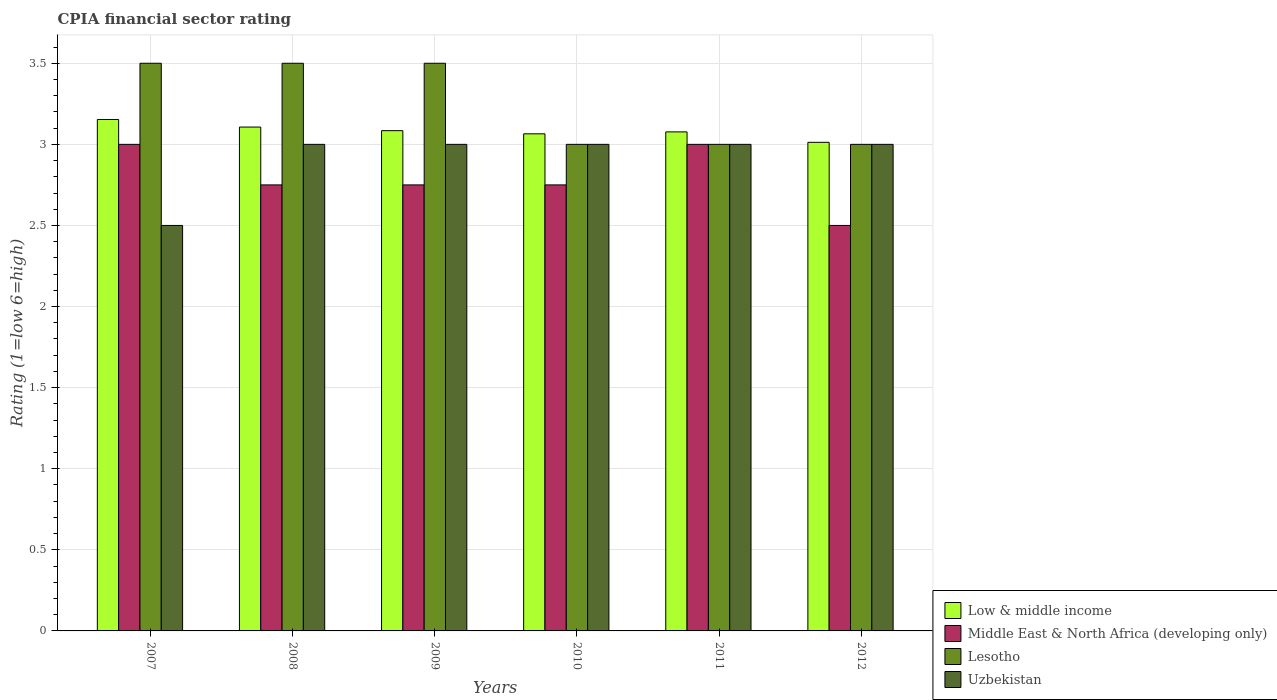How many different coloured bars are there?
Offer a very short reply. 4. How many groups of bars are there?
Your response must be concise. 6. How many bars are there on the 5th tick from the left?
Offer a terse response. 4. What is the label of the 5th group of bars from the left?
Your answer should be very brief. 2011. In how many cases, is the number of bars for a given year not equal to the number of legend labels?
Your answer should be very brief. 0. What is the total CPIA rating in Middle East & North Africa (developing only) in the graph?
Offer a very short reply. 16.75. What is the difference between the CPIA rating in Low & middle income in 2010 and that in 2011?
Offer a terse response. -0.01. What is the difference between the CPIA rating in Uzbekistan in 2007 and the CPIA rating in Low & middle income in 2010?
Provide a succinct answer. -0.56. What is the average CPIA rating in Low & middle income per year?
Offer a terse response. 3.08. In the year 2011, what is the difference between the CPIA rating in Lesotho and CPIA rating in Low & middle income?
Make the answer very short. -0.08. In how many years, is the CPIA rating in Low & middle income greater than 2.6?
Provide a succinct answer. 6. What is the ratio of the CPIA rating in Middle East & North Africa (developing only) in 2007 to that in 2010?
Offer a terse response. 1.09. Is the CPIA rating in Lesotho in 2008 less than that in 2009?
Ensure brevity in your answer.  No. What is the difference between the highest and the second highest CPIA rating in Lesotho?
Provide a succinct answer. 0. In how many years, is the CPIA rating in Middle East & North Africa (developing only) greater than the average CPIA rating in Middle East & North Africa (developing only) taken over all years?
Give a very brief answer. 2. What does the 2nd bar from the left in 2010 represents?
Offer a very short reply. Middle East & North Africa (developing only). What does the 1st bar from the right in 2011 represents?
Provide a short and direct response. Uzbekistan. Does the graph contain any zero values?
Offer a very short reply. No. Does the graph contain grids?
Provide a short and direct response. Yes. Where does the legend appear in the graph?
Your answer should be compact. Bottom right. How many legend labels are there?
Give a very brief answer. 4. What is the title of the graph?
Your response must be concise. CPIA financial sector rating. What is the label or title of the X-axis?
Your response must be concise. Years. What is the label or title of the Y-axis?
Give a very brief answer. Rating (1=low 6=high). What is the Rating (1=low 6=high) in Low & middle income in 2007?
Ensure brevity in your answer.  3.15. What is the Rating (1=low 6=high) of Lesotho in 2007?
Your answer should be very brief. 3.5. What is the Rating (1=low 6=high) of Low & middle income in 2008?
Your response must be concise. 3.11. What is the Rating (1=low 6=high) in Middle East & North Africa (developing only) in 2008?
Offer a terse response. 2.75. What is the Rating (1=low 6=high) in Low & middle income in 2009?
Your answer should be compact. 3.08. What is the Rating (1=low 6=high) in Middle East & North Africa (developing only) in 2009?
Provide a succinct answer. 2.75. What is the Rating (1=low 6=high) of Lesotho in 2009?
Your response must be concise. 3.5. What is the Rating (1=low 6=high) in Low & middle income in 2010?
Your answer should be very brief. 3.06. What is the Rating (1=low 6=high) of Middle East & North Africa (developing only) in 2010?
Offer a very short reply. 2.75. What is the Rating (1=low 6=high) in Lesotho in 2010?
Ensure brevity in your answer.  3. What is the Rating (1=low 6=high) of Low & middle income in 2011?
Keep it short and to the point. 3.08. What is the Rating (1=low 6=high) of Low & middle income in 2012?
Provide a succinct answer. 3.01. What is the Rating (1=low 6=high) in Middle East & North Africa (developing only) in 2012?
Make the answer very short. 2.5. What is the Rating (1=low 6=high) in Lesotho in 2012?
Your response must be concise. 3. Across all years, what is the maximum Rating (1=low 6=high) of Low & middle income?
Provide a succinct answer. 3.15. Across all years, what is the maximum Rating (1=low 6=high) of Middle East & North Africa (developing only)?
Your answer should be compact. 3. Across all years, what is the maximum Rating (1=low 6=high) of Uzbekistan?
Offer a very short reply. 3. Across all years, what is the minimum Rating (1=low 6=high) in Low & middle income?
Keep it short and to the point. 3.01. Across all years, what is the minimum Rating (1=low 6=high) of Lesotho?
Ensure brevity in your answer.  3. What is the total Rating (1=low 6=high) of Low & middle income in the graph?
Provide a short and direct response. 18.5. What is the total Rating (1=low 6=high) in Middle East & North Africa (developing only) in the graph?
Your response must be concise. 16.75. What is the total Rating (1=low 6=high) of Uzbekistan in the graph?
Your response must be concise. 17.5. What is the difference between the Rating (1=low 6=high) of Low & middle income in 2007 and that in 2008?
Offer a very short reply. 0.05. What is the difference between the Rating (1=low 6=high) of Lesotho in 2007 and that in 2008?
Ensure brevity in your answer.  0. What is the difference between the Rating (1=low 6=high) of Low & middle income in 2007 and that in 2009?
Your response must be concise. 0.07. What is the difference between the Rating (1=low 6=high) of Middle East & North Africa (developing only) in 2007 and that in 2009?
Ensure brevity in your answer.  0.25. What is the difference between the Rating (1=low 6=high) in Lesotho in 2007 and that in 2009?
Provide a short and direct response. 0. What is the difference between the Rating (1=low 6=high) of Low & middle income in 2007 and that in 2010?
Make the answer very short. 0.09. What is the difference between the Rating (1=low 6=high) of Low & middle income in 2007 and that in 2011?
Give a very brief answer. 0.08. What is the difference between the Rating (1=low 6=high) in Middle East & North Africa (developing only) in 2007 and that in 2011?
Your answer should be very brief. 0. What is the difference between the Rating (1=low 6=high) in Low & middle income in 2007 and that in 2012?
Your response must be concise. 0.14. What is the difference between the Rating (1=low 6=high) in Middle East & North Africa (developing only) in 2007 and that in 2012?
Provide a short and direct response. 0.5. What is the difference between the Rating (1=low 6=high) of Low & middle income in 2008 and that in 2009?
Your response must be concise. 0.02. What is the difference between the Rating (1=low 6=high) of Middle East & North Africa (developing only) in 2008 and that in 2009?
Your answer should be very brief. 0. What is the difference between the Rating (1=low 6=high) in Low & middle income in 2008 and that in 2010?
Ensure brevity in your answer.  0.04. What is the difference between the Rating (1=low 6=high) in Low & middle income in 2008 and that in 2011?
Ensure brevity in your answer.  0.03. What is the difference between the Rating (1=low 6=high) in Lesotho in 2008 and that in 2011?
Provide a succinct answer. 0.5. What is the difference between the Rating (1=low 6=high) in Low & middle income in 2008 and that in 2012?
Make the answer very short. 0.09. What is the difference between the Rating (1=low 6=high) in Middle East & North Africa (developing only) in 2008 and that in 2012?
Provide a short and direct response. 0.25. What is the difference between the Rating (1=low 6=high) of Lesotho in 2008 and that in 2012?
Provide a short and direct response. 0.5. What is the difference between the Rating (1=low 6=high) of Low & middle income in 2009 and that in 2010?
Your answer should be compact. 0.02. What is the difference between the Rating (1=low 6=high) of Middle East & North Africa (developing only) in 2009 and that in 2010?
Provide a succinct answer. 0. What is the difference between the Rating (1=low 6=high) in Lesotho in 2009 and that in 2010?
Keep it short and to the point. 0.5. What is the difference between the Rating (1=low 6=high) of Uzbekistan in 2009 and that in 2010?
Give a very brief answer. 0. What is the difference between the Rating (1=low 6=high) in Low & middle income in 2009 and that in 2011?
Ensure brevity in your answer.  0.01. What is the difference between the Rating (1=low 6=high) of Middle East & North Africa (developing only) in 2009 and that in 2011?
Make the answer very short. -0.25. What is the difference between the Rating (1=low 6=high) of Lesotho in 2009 and that in 2011?
Offer a terse response. 0.5. What is the difference between the Rating (1=low 6=high) of Low & middle income in 2009 and that in 2012?
Your answer should be compact. 0.07. What is the difference between the Rating (1=low 6=high) in Middle East & North Africa (developing only) in 2009 and that in 2012?
Provide a short and direct response. 0.25. What is the difference between the Rating (1=low 6=high) in Uzbekistan in 2009 and that in 2012?
Offer a terse response. 0. What is the difference between the Rating (1=low 6=high) in Low & middle income in 2010 and that in 2011?
Keep it short and to the point. -0.01. What is the difference between the Rating (1=low 6=high) of Uzbekistan in 2010 and that in 2011?
Your answer should be compact. 0. What is the difference between the Rating (1=low 6=high) of Low & middle income in 2010 and that in 2012?
Ensure brevity in your answer.  0.05. What is the difference between the Rating (1=low 6=high) in Middle East & North Africa (developing only) in 2010 and that in 2012?
Keep it short and to the point. 0.25. What is the difference between the Rating (1=low 6=high) of Uzbekistan in 2010 and that in 2012?
Your response must be concise. 0. What is the difference between the Rating (1=low 6=high) of Low & middle income in 2011 and that in 2012?
Provide a succinct answer. 0.06. What is the difference between the Rating (1=low 6=high) in Lesotho in 2011 and that in 2012?
Your answer should be compact. 0. What is the difference between the Rating (1=low 6=high) of Low & middle income in 2007 and the Rating (1=low 6=high) of Middle East & North Africa (developing only) in 2008?
Give a very brief answer. 0.4. What is the difference between the Rating (1=low 6=high) in Low & middle income in 2007 and the Rating (1=low 6=high) in Lesotho in 2008?
Make the answer very short. -0.35. What is the difference between the Rating (1=low 6=high) in Low & middle income in 2007 and the Rating (1=low 6=high) in Uzbekistan in 2008?
Your answer should be compact. 0.15. What is the difference between the Rating (1=low 6=high) of Middle East & North Africa (developing only) in 2007 and the Rating (1=low 6=high) of Uzbekistan in 2008?
Keep it short and to the point. 0. What is the difference between the Rating (1=low 6=high) of Lesotho in 2007 and the Rating (1=low 6=high) of Uzbekistan in 2008?
Offer a terse response. 0.5. What is the difference between the Rating (1=low 6=high) in Low & middle income in 2007 and the Rating (1=low 6=high) in Middle East & North Africa (developing only) in 2009?
Provide a succinct answer. 0.4. What is the difference between the Rating (1=low 6=high) in Low & middle income in 2007 and the Rating (1=low 6=high) in Lesotho in 2009?
Provide a succinct answer. -0.35. What is the difference between the Rating (1=low 6=high) in Low & middle income in 2007 and the Rating (1=low 6=high) in Uzbekistan in 2009?
Provide a succinct answer. 0.15. What is the difference between the Rating (1=low 6=high) in Middle East & North Africa (developing only) in 2007 and the Rating (1=low 6=high) in Uzbekistan in 2009?
Your response must be concise. 0. What is the difference between the Rating (1=low 6=high) in Lesotho in 2007 and the Rating (1=low 6=high) in Uzbekistan in 2009?
Provide a short and direct response. 0.5. What is the difference between the Rating (1=low 6=high) of Low & middle income in 2007 and the Rating (1=low 6=high) of Middle East & North Africa (developing only) in 2010?
Offer a very short reply. 0.4. What is the difference between the Rating (1=low 6=high) of Low & middle income in 2007 and the Rating (1=low 6=high) of Lesotho in 2010?
Provide a succinct answer. 0.15. What is the difference between the Rating (1=low 6=high) in Low & middle income in 2007 and the Rating (1=low 6=high) in Uzbekistan in 2010?
Keep it short and to the point. 0.15. What is the difference between the Rating (1=low 6=high) of Lesotho in 2007 and the Rating (1=low 6=high) of Uzbekistan in 2010?
Provide a short and direct response. 0.5. What is the difference between the Rating (1=low 6=high) of Low & middle income in 2007 and the Rating (1=low 6=high) of Middle East & North Africa (developing only) in 2011?
Give a very brief answer. 0.15. What is the difference between the Rating (1=low 6=high) of Low & middle income in 2007 and the Rating (1=low 6=high) of Lesotho in 2011?
Your answer should be very brief. 0.15. What is the difference between the Rating (1=low 6=high) in Low & middle income in 2007 and the Rating (1=low 6=high) in Uzbekistan in 2011?
Your answer should be compact. 0.15. What is the difference between the Rating (1=low 6=high) in Middle East & North Africa (developing only) in 2007 and the Rating (1=low 6=high) in Lesotho in 2011?
Provide a short and direct response. 0. What is the difference between the Rating (1=low 6=high) in Middle East & North Africa (developing only) in 2007 and the Rating (1=low 6=high) in Uzbekistan in 2011?
Your answer should be compact. 0. What is the difference between the Rating (1=low 6=high) in Lesotho in 2007 and the Rating (1=low 6=high) in Uzbekistan in 2011?
Your answer should be very brief. 0.5. What is the difference between the Rating (1=low 6=high) in Low & middle income in 2007 and the Rating (1=low 6=high) in Middle East & North Africa (developing only) in 2012?
Your answer should be very brief. 0.65. What is the difference between the Rating (1=low 6=high) of Low & middle income in 2007 and the Rating (1=low 6=high) of Lesotho in 2012?
Your response must be concise. 0.15. What is the difference between the Rating (1=low 6=high) of Low & middle income in 2007 and the Rating (1=low 6=high) of Uzbekistan in 2012?
Give a very brief answer. 0.15. What is the difference between the Rating (1=low 6=high) of Middle East & North Africa (developing only) in 2007 and the Rating (1=low 6=high) of Uzbekistan in 2012?
Provide a succinct answer. 0. What is the difference between the Rating (1=low 6=high) in Lesotho in 2007 and the Rating (1=low 6=high) in Uzbekistan in 2012?
Provide a succinct answer. 0.5. What is the difference between the Rating (1=low 6=high) in Low & middle income in 2008 and the Rating (1=low 6=high) in Middle East & North Africa (developing only) in 2009?
Your answer should be very brief. 0.36. What is the difference between the Rating (1=low 6=high) of Low & middle income in 2008 and the Rating (1=low 6=high) of Lesotho in 2009?
Give a very brief answer. -0.39. What is the difference between the Rating (1=low 6=high) of Low & middle income in 2008 and the Rating (1=low 6=high) of Uzbekistan in 2009?
Keep it short and to the point. 0.11. What is the difference between the Rating (1=low 6=high) of Middle East & North Africa (developing only) in 2008 and the Rating (1=low 6=high) of Lesotho in 2009?
Your response must be concise. -0.75. What is the difference between the Rating (1=low 6=high) of Low & middle income in 2008 and the Rating (1=low 6=high) of Middle East & North Africa (developing only) in 2010?
Make the answer very short. 0.36. What is the difference between the Rating (1=low 6=high) of Low & middle income in 2008 and the Rating (1=low 6=high) of Lesotho in 2010?
Give a very brief answer. 0.11. What is the difference between the Rating (1=low 6=high) of Low & middle income in 2008 and the Rating (1=low 6=high) of Uzbekistan in 2010?
Make the answer very short. 0.11. What is the difference between the Rating (1=low 6=high) in Middle East & North Africa (developing only) in 2008 and the Rating (1=low 6=high) in Lesotho in 2010?
Your answer should be compact. -0.25. What is the difference between the Rating (1=low 6=high) in Middle East & North Africa (developing only) in 2008 and the Rating (1=low 6=high) in Uzbekistan in 2010?
Offer a terse response. -0.25. What is the difference between the Rating (1=low 6=high) of Lesotho in 2008 and the Rating (1=low 6=high) of Uzbekistan in 2010?
Keep it short and to the point. 0.5. What is the difference between the Rating (1=low 6=high) in Low & middle income in 2008 and the Rating (1=low 6=high) in Middle East & North Africa (developing only) in 2011?
Your response must be concise. 0.11. What is the difference between the Rating (1=low 6=high) of Low & middle income in 2008 and the Rating (1=low 6=high) of Lesotho in 2011?
Keep it short and to the point. 0.11. What is the difference between the Rating (1=low 6=high) of Low & middle income in 2008 and the Rating (1=low 6=high) of Uzbekistan in 2011?
Offer a very short reply. 0.11. What is the difference between the Rating (1=low 6=high) in Middle East & North Africa (developing only) in 2008 and the Rating (1=low 6=high) in Lesotho in 2011?
Keep it short and to the point. -0.25. What is the difference between the Rating (1=low 6=high) of Low & middle income in 2008 and the Rating (1=low 6=high) of Middle East & North Africa (developing only) in 2012?
Ensure brevity in your answer.  0.61. What is the difference between the Rating (1=low 6=high) of Low & middle income in 2008 and the Rating (1=low 6=high) of Lesotho in 2012?
Ensure brevity in your answer.  0.11. What is the difference between the Rating (1=low 6=high) of Low & middle income in 2008 and the Rating (1=low 6=high) of Uzbekistan in 2012?
Keep it short and to the point. 0.11. What is the difference between the Rating (1=low 6=high) in Middle East & North Africa (developing only) in 2008 and the Rating (1=low 6=high) in Uzbekistan in 2012?
Offer a terse response. -0.25. What is the difference between the Rating (1=low 6=high) of Lesotho in 2008 and the Rating (1=low 6=high) of Uzbekistan in 2012?
Your answer should be compact. 0.5. What is the difference between the Rating (1=low 6=high) in Low & middle income in 2009 and the Rating (1=low 6=high) in Middle East & North Africa (developing only) in 2010?
Make the answer very short. 0.33. What is the difference between the Rating (1=low 6=high) in Low & middle income in 2009 and the Rating (1=low 6=high) in Lesotho in 2010?
Provide a succinct answer. 0.08. What is the difference between the Rating (1=low 6=high) in Low & middle income in 2009 and the Rating (1=low 6=high) in Uzbekistan in 2010?
Offer a terse response. 0.08. What is the difference between the Rating (1=low 6=high) of Low & middle income in 2009 and the Rating (1=low 6=high) of Middle East & North Africa (developing only) in 2011?
Your answer should be compact. 0.08. What is the difference between the Rating (1=low 6=high) of Low & middle income in 2009 and the Rating (1=low 6=high) of Lesotho in 2011?
Give a very brief answer. 0.08. What is the difference between the Rating (1=low 6=high) of Low & middle income in 2009 and the Rating (1=low 6=high) of Uzbekistan in 2011?
Your response must be concise. 0.08. What is the difference between the Rating (1=low 6=high) in Middle East & North Africa (developing only) in 2009 and the Rating (1=low 6=high) in Uzbekistan in 2011?
Offer a very short reply. -0.25. What is the difference between the Rating (1=low 6=high) of Lesotho in 2009 and the Rating (1=low 6=high) of Uzbekistan in 2011?
Give a very brief answer. 0.5. What is the difference between the Rating (1=low 6=high) in Low & middle income in 2009 and the Rating (1=low 6=high) in Middle East & North Africa (developing only) in 2012?
Your response must be concise. 0.58. What is the difference between the Rating (1=low 6=high) of Low & middle income in 2009 and the Rating (1=low 6=high) of Lesotho in 2012?
Your response must be concise. 0.08. What is the difference between the Rating (1=low 6=high) of Low & middle income in 2009 and the Rating (1=low 6=high) of Uzbekistan in 2012?
Provide a succinct answer. 0.08. What is the difference between the Rating (1=low 6=high) in Middle East & North Africa (developing only) in 2009 and the Rating (1=low 6=high) in Uzbekistan in 2012?
Give a very brief answer. -0.25. What is the difference between the Rating (1=low 6=high) in Low & middle income in 2010 and the Rating (1=low 6=high) in Middle East & North Africa (developing only) in 2011?
Provide a succinct answer. 0.06. What is the difference between the Rating (1=low 6=high) in Low & middle income in 2010 and the Rating (1=low 6=high) in Lesotho in 2011?
Keep it short and to the point. 0.06. What is the difference between the Rating (1=low 6=high) in Low & middle income in 2010 and the Rating (1=low 6=high) in Uzbekistan in 2011?
Your response must be concise. 0.06. What is the difference between the Rating (1=low 6=high) in Middle East & North Africa (developing only) in 2010 and the Rating (1=low 6=high) in Uzbekistan in 2011?
Ensure brevity in your answer.  -0.25. What is the difference between the Rating (1=low 6=high) of Lesotho in 2010 and the Rating (1=low 6=high) of Uzbekistan in 2011?
Your response must be concise. 0. What is the difference between the Rating (1=low 6=high) in Low & middle income in 2010 and the Rating (1=low 6=high) in Middle East & North Africa (developing only) in 2012?
Your response must be concise. 0.56. What is the difference between the Rating (1=low 6=high) in Low & middle income in 2010 and the Rating (1=low 6=high) in Lesotho in 2012?
Keep it short and to the point. 0.06. What is the difference between the Rating (1=low 6=high) of Low & middle income in 2010 and the Rating (1=low 6=high) of Uzbekistan in 2012?
Keep it short and to the point. 0.06. What is the difference between the Rating (1=low 6=high) of Middle East & North Africa (developing only) in 2010 and the Rating (1=low 6=high) of Uzbekistan in 2012?
Ensure brevity in your answer.  -0.25. What is the difference between the Rating (1=low 6=high) in Low & middle income in 2011 and the Rating (1=low 6=high) in Middle East & North Africa (developing only) in 2012?
Your answer should be very brief. 0.58. What is the difference between the Rating (1=low 6=high) of Low & middle income in 2011 and the Rating (1=low 6=high) of Lesotho in 2012?
Your answer should be compact. 0.08. What is the difference between the Rating (1=low 6=high) in Low & middle income in 2011 and the Rating (1=low 6=high) in Uzbekistan in 2012?
Provide a short and direct response. 0.08. What is the difference between the Rating (1=low 6=high) of Middle East & North Africa (developing only) in 2011 and the Rating (1=low 6=high) of Lesotho in 2012?
Offer a terse response. 0. What is the difference between the Rating (1=low 6=high) of Middle East & North Africa (developing only) in 2011 and the Rating (1=low 6=high) of Uzbekistan in 2012?
Offer a very short reply. 0. What is the average Rating (1=low 6=high) of Low & middle income per year?
Your answer should be very brief. 3.08. What is the average Rating (1=low 6=high) of Middle East & North Africa (developing only) per year?
Offer a terse response. 2.79. What is the average Rating (1=low 6=high) in Lesotho per year?
Offer a terse response. 3.25. What is the average Rating (1=low 6=high) in Uzbekistan per year?
Offer a very short reply. 2.92. In the year 2007, what is the difference between the Rating (1=low 6=high) of Low & middle income and Rating (1=low 6=high) of Middle East & North Africa (developing only)?
Offer a terse response. 0.15. In the year 2007, what is the difference between the Rating (1=low 6=high) of Low & middle income and Rating (1=low 6=high) of Lesotho?
Your answer should be compact. -0.35. In the year 2007, what is the difference between the Rating (1=low 6=high) in Low & middle income and Rating (1=low 6=high) in Uzbekistan?
Offer a very short reply. 0.65. In the year 2007, what is the difference between the Rating (1=low 6=high) in Middle East & North Africa (developing only) and Rating (1=low 6=high) in Uzbekistan?
Make the answer very short. 0.5. In the year 2008, what is the difference between the Rating (1=low 6=high) in Low & middle income and Rating (1=low 6=high) in Middle East & North Africa (developing only)?
Your response must be concise. 0.36. In the year 2008, what is the difference between the Rating (1=low 6=high) of Low & middle income and Rating (1=low 6=high) of Lesotho?
Your response must be concise. -0.39. In the year 2008, what is the difference between the Rating (1=low 6=high) in Low & middle income and Rating (1=low 6=high) in Uzbekistan?
Ensure brevity in your answer.  0.11. In the year 2008, what is the difference between the Rating (1=low 6=high) in Middle East & North Africa (developing only) and Rating (1=low 6=high) in Lesotho?
Give a very brief answer. -0.75. In the year 2008, what is the difference between the Rating (1=low 6=high) in Middle East & North Africa (developing only) and Rating (1=low 6=high) in Uzbekistan?
Offer a very short reply. -0.25. In the year 2008, what is the difference between the Rating (1=low 6=high) of Lesotho and Rating (1=low 6=high) of Uzbekistan?
Keep it short and to the point. 0.5. In the year 2009, what is the difference between the Rating (1=low 6=high) in Low & middle income and Rating (1=low 6=high) in Middle East & North Africa (developing only)?
Your answer should be compact. 0.33. In the year 2009, what is the difference between the Rating (1=low 6=high) in Low & middle income and Rating (1=low 6=high) in Lesotho?
Your response must be concise. -0.42. In the year 2009, what is the difference between the Rating (1=low 6=high) of Low & middle income and Rating (1=low 6=high) of Uzbekistan?
Your answer should be very brief. 0.08. In the year 2009, what is the difference between the Rating (1=low 6=high) of Middle East & North Africa (developing only) and Rating (1=low 6=high) of Lesotho?
Make the answer very short. -0.75. In the year 2010, what is the difference between the Rating (1=low 6=high) in Low & middle income and Rating (1=low 6=high) in Middle East & North Africa (developing only)?
Your response must be concise. 0.31. In the year 2010, what is the difference between the Rating (1=low 6=high) in Low & middle income and Rating (1=low 6=high) in Lesotho?
Offer a terse response. 0.06. In the year 2010, what is the difference between the Rating (1=low 6=high) in Low & middle income and Rating (1=low 6=high) in Uzbekistan?
Give a very brief answer. 0.06. In the year 2010, what is the difference between the Rating (1=low 6=high) of Middle East & North Africa (developing only) and Rating (1=low 6=high) of Lesotho?
Provide a succinct answer. -0.25. In the year 2010, what is the difference between the Rating (1=low 6=high) in Middle East & North Africa (developing only) and Rating (1=low 6=high) in Uzbekistan?
Keep it short and to the point. -0.25. In the year 2010, what is the difference between the Rating (1=low 6=high) in Lesotho and Rating (1=low 6=high) in Uzbekistan?
Provide a succinct answer. 0. In the year 2011, what is the difference between the Rating (1=low 6=high) of Low & middle income and Rating (1=low 6=high) of Middle East & North Africa (developing only)?
Make the answer very short. 0.08. In the year 2011, what is the difference between the Rating (1=low 6=high) in Low & middle income and Rating (1=low 6=high) in Lesotho?
Keep it short and to the point. 0.08. In the year 2011, what is the difference between the Rating (1=low 6=high) of Low & middle income and Rating (1=low 6=high) of Uzbekistan?
Offer a very short reply. 0.08. In the year 2011, what is the difference between the Rating (1=low 6=high) of Middle East & North Africa (developing only) and Rating (1=low 6=high) of Lesotho?
Make the answer very short. 0. In the year 2011, what is the difference between the Rating (1=low 6=high) in Lesotho and Rating (1=low 6=high) in Uzbekistan?
Ensure brevity in your answer.  0. In the year 2012, what is the difference between the Rating (1=low 6=high) of Low & middle income and Rating (1=low 6=high) of Middle East & North Africa (developing only)?
Give a very brief answer. 0.51. In the year 2012, what is the difference between the Rating (1=low 6=high) in Low & middle income and Rating (1=low 6=high) in Lesotho?
Provide a short and direct response. 0.01. In the year 2012, what is the difference between the Rating (1=low 6=high) of Low & middle income and Rating (1=low 6=high) of Uzbekistan?
Your response must be concise. 0.01. In the year 2012, what is the difference between the Rating (1=low 6=high) of Middle East & North Africa (developing only) and Rating (1=low 6=high) of Lesotho?
Provide a succinct answer. -0.5. What is the ratio of the Rating (1=low 6=high) in Low & middle income in 2007 to that in 2008?
Offer a terse response. 1.01. What is the ratio of the Rating (1=low 6=high) in Middle East & North Africa (developing only) in 2007 to that in 2008?
Keep it short and to the point. 1.09. What is the ratio of the Rating (1=low 6=high) of Low & middle income in 2007 to that in 2009?
Your response must be concise. 1.02. What is the ratio of the Rating (1=low 6=high) in Middle East & North Africa (developing only) in 2007 to that in 2009?
Offer a terse response. 1.09. What is the ratio of the Rating (1=low 6=high) in Lesotho in 2007 to that in 2009?
Your answer should be compact. 1. What is the ratio of the Rating (1=low 6=high) in Uzbekistan in 2007 to that in 2009?
Provide a short and direct response. 0.83. What is the ratio of the Rating (1=low 6=high) of Low & middle income in 2007 to that in 2010?
Your answer should be compact. 1.03. What is the ratio of the Rating (1=low 6=high) in Lesotho in 2007 to that in 2010?
Offer a terse response. 1.17. What is the ratio of the Rating (1=low 6=high) of Low & middle income in 2007 to that in 2011?
Make the answer very short. 1.02. What is the ratio of the Rating (1=low 6=high) of Middle East & North Africa (developing only) in 2007 to that in 2011?
Provide a succinct answer. 1. What is the ratio of the Rating (1=low 6=high) of Uzbekistan in 2007 to that in 2011?
Provide a short and direct response. 0.83. What is the ratio of the Rating (1=low 6=high) of Low & middle income in 2007 to that in 2012?
Offer a terse response. 1.05. What is the ratio of the Rating (1=low 6=high) in Middle East & North Africa (developing only) in 2007 to that in 2012?
Make the answer very short. 1.2. What is the ratio of the Rating (1=low 6=high) of Uzbekistan in 2007 to that in 2012?
Keep it short and to the point. 0.83. What is the ratio of the Rating (1=low 6=high) in Low & middle income in 2008 to that in 2009?
Provide a succinct answer. 1.01. What is the ratio of the Rating (1=low 6=high) in Middle East & North Africa (developing only) in 2008 to that in 2009?
Ensure brevity in your answer.  1. What is the ratio of the Rating (1=low 6=high) of Lesotho in 2008 to that in 2009?
Offer a terse response. 1. What is the ratio of the Rating (1=low 6=high) of Uzbekistan in 2008 to that in 2009?
Give a very brief answer. 1. What is the ratio of the Rating (1=low 6=high) in Low & middle income in 2008 to that in 2010?
Provide a short and direct response. 1.01. What is the ratio of the Rating (1=low 6=high) of Uzbekistan in 2008 to that in 2010?
Offer a very short reply. 1. What is the ratio of the Rating (1=low 6=high) of Low & middle income in 2008 to that in 2011?
Provide a short and direct response. 1.01. What is the ratio of the Rating (1=low 6=high) of Lesotho in 2008 to that in 2011?
Provide a succinct answer. 1.17. What is the ratio of the Rating (1=low 6=high) of Uzbekistan in 2008 to that in 2011?
Your answer should be very brief. 1. What is the ratio of the Rating (1=low 6=high) in Low & middle income in 2008 to that in 2012?
Provide a succinct answer. 1.03. What is the ratio of the Rating (1=low 6=high) of Uzbekistan in 2008 to that in 2012?
Your response must be concise. 1. What is the ratio of the Rating (1=low 6=high) of Low & middle income in 2009 to that in 2010?
Ensure brevity in your answer.  1.01. What is the ratio of the Rating (1=low 6=high) in Middle East & North Africa (developing only) in 2009 to that in 2010?
Your answer should be very brief. 1. What is the ratio of the Rating (1=low 6=high) of Lesotho in 2009 to that in 2010?
Your response must be concise. 1.17. What is the ratio of the Rating (1=low 6=high) of Uzbekistan in 2009 to that in 2010?
Offer a very short reply. 1. What is the ratio of the Rating (1=low 6=high) of Low & middle income in 2009 to that in 2011?
Offer a very short reply. 1. What is the ratio of the Rating (1=low 6=high) in Uzbekistan in 2009 to that in 2011?
Offer a terse response. 1. What is the ratio of the Rating (1=low 6=high) in Low & middle income in 2009 to that in 2012?
Your answer should be compact. 1.02. What is the ratio of the Rating (1=low 6=high) of Middle East & North Africa (developing only) in 2009 to that in 2012?
Provide a succinct answer. 1.1. What is the ratio of the Rating (1=low 6=high) in Lesotho in 2009 to that in 2012?
Your response must be concise. 1.17. What is the ratio of the Rating (1=low 6=high) in Uzbekistan in 2009 to that in 2012?
Make the answer very short. 1. What is the ratio of the Rating (1=low 6=high) of Lesotho in 2010 to that in 2011?
Ensure brevity in your answer.  1. What is the ratio of the Rating (1=low 6=high) of Uzbekistan in 2010 to that in 2011?
Offer a very short reply. 1. What is the ratio of the Rating (1=low 6=high) of Low & middle income in 2010 to that in 2012?
Your response must be concise. 1.02. What is the ratio of the Rating (1=low 6=high) in Middle East & North Africa (developing only) in 2010 to that in 2012?
Your answer should be compact. 1.1. What is the ratio of the Rating (1=low 6=high) in Uzbekistan in 2010 to that in 2012?
Offer a very short reply. 1. What is the ratio of the Rating (1=low 6=high) in Low & middle income in 2011 to that in 2012?
Provide a short and direct response. 1.02. What is the ratio of the Rating (1=low 6=high) of Middle East & North Africa (developing only) in 2011 to that in 2012?
Ensure brevity in your answer.  1.2. What is the ratio of the Rating (1=low 6=high) in Lesotho in 2011 to that in 2012?
Your answer should be very brief. 1. What is the ratio of the Rating (1=low 6=high) in Uzbekistan in 2011 to that in 2012?
Make the answer very short. 1. What is the difference between the highest and the second highest Rating (1=low 6=high) in Low & middle income?
Keep it short and to the point. 0.05. What is the difference between the highest and the second highest Rating (1=low 6=high) in Lesotho?
Make the answer very short. 0. What is the difference between the highest and the second highest Rating (1=low 6=high) in Uzbekistan?
Provide a short and direct response. 0. What is the difference between the highest and the lowest Rating (1=low 6=high) of Low & middle income?
Your response must be concise. 0.14. 